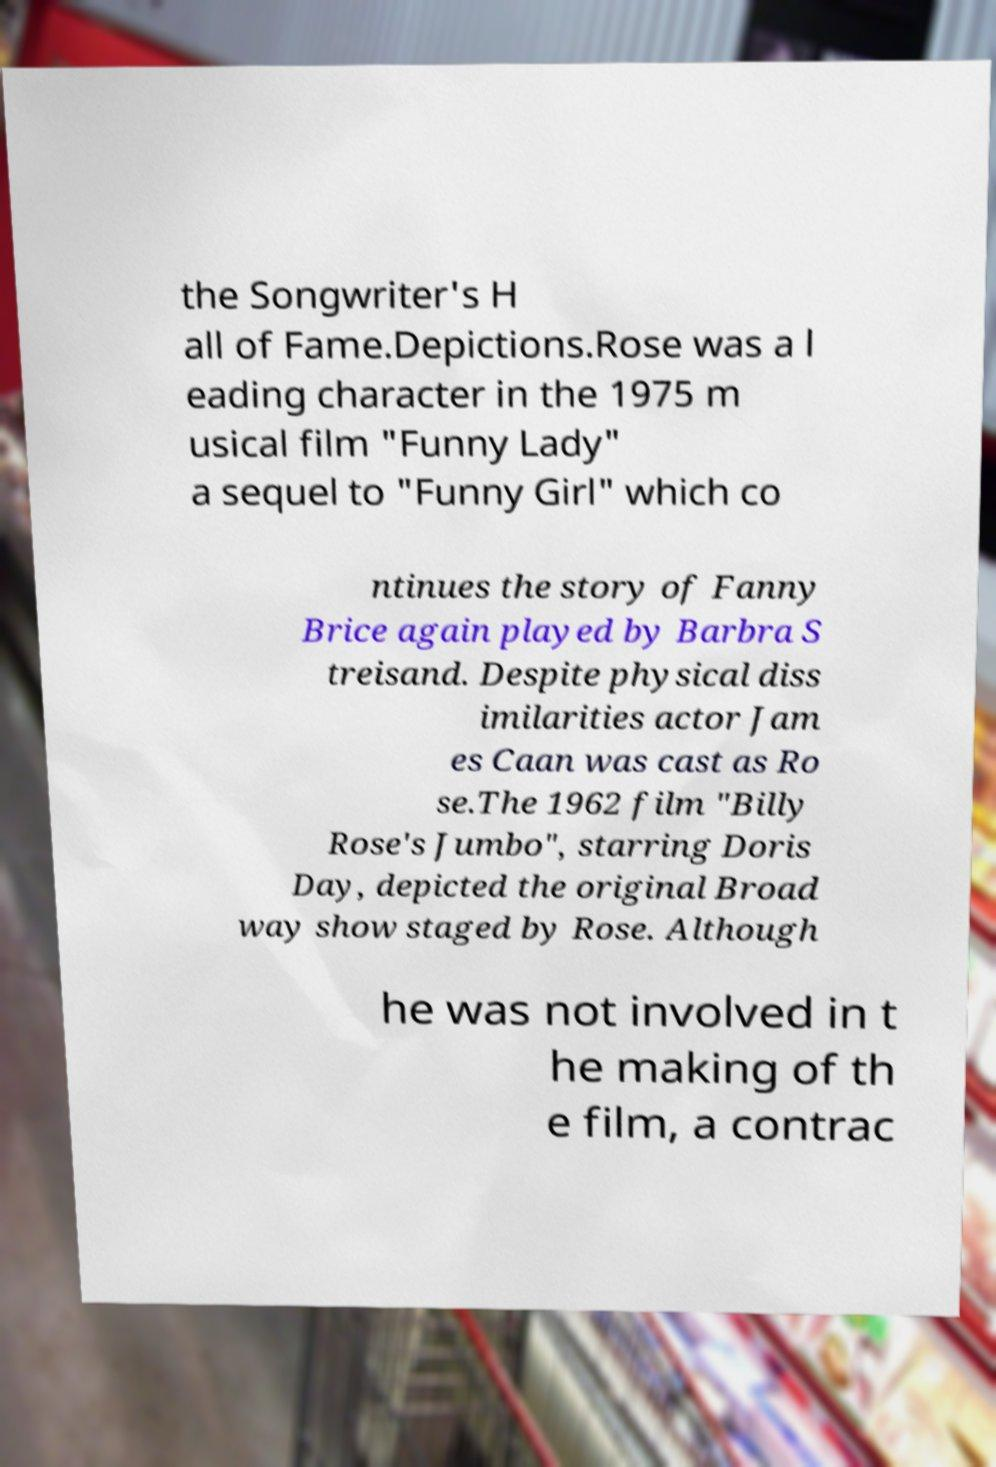What messages or text are displayed in this image? I need them in a readable, typed format. the Songwriter's H all of Fame.Depictions.Rose was a l eading character in the 1975 m usical film "Funny Lady" a sequel to "Funny Girl" which co ntinues the story of Fanny Brice again played by Barbra S treisand. Despite physical diss imilarities actor Jam es Caan was cast as Ro se.The 1962 film "Billy Rose's Jumbo", starring Doris Day, depicted the original Broad way show staged by Rose. Although he was not involved in t he making of th e film, a contrac 